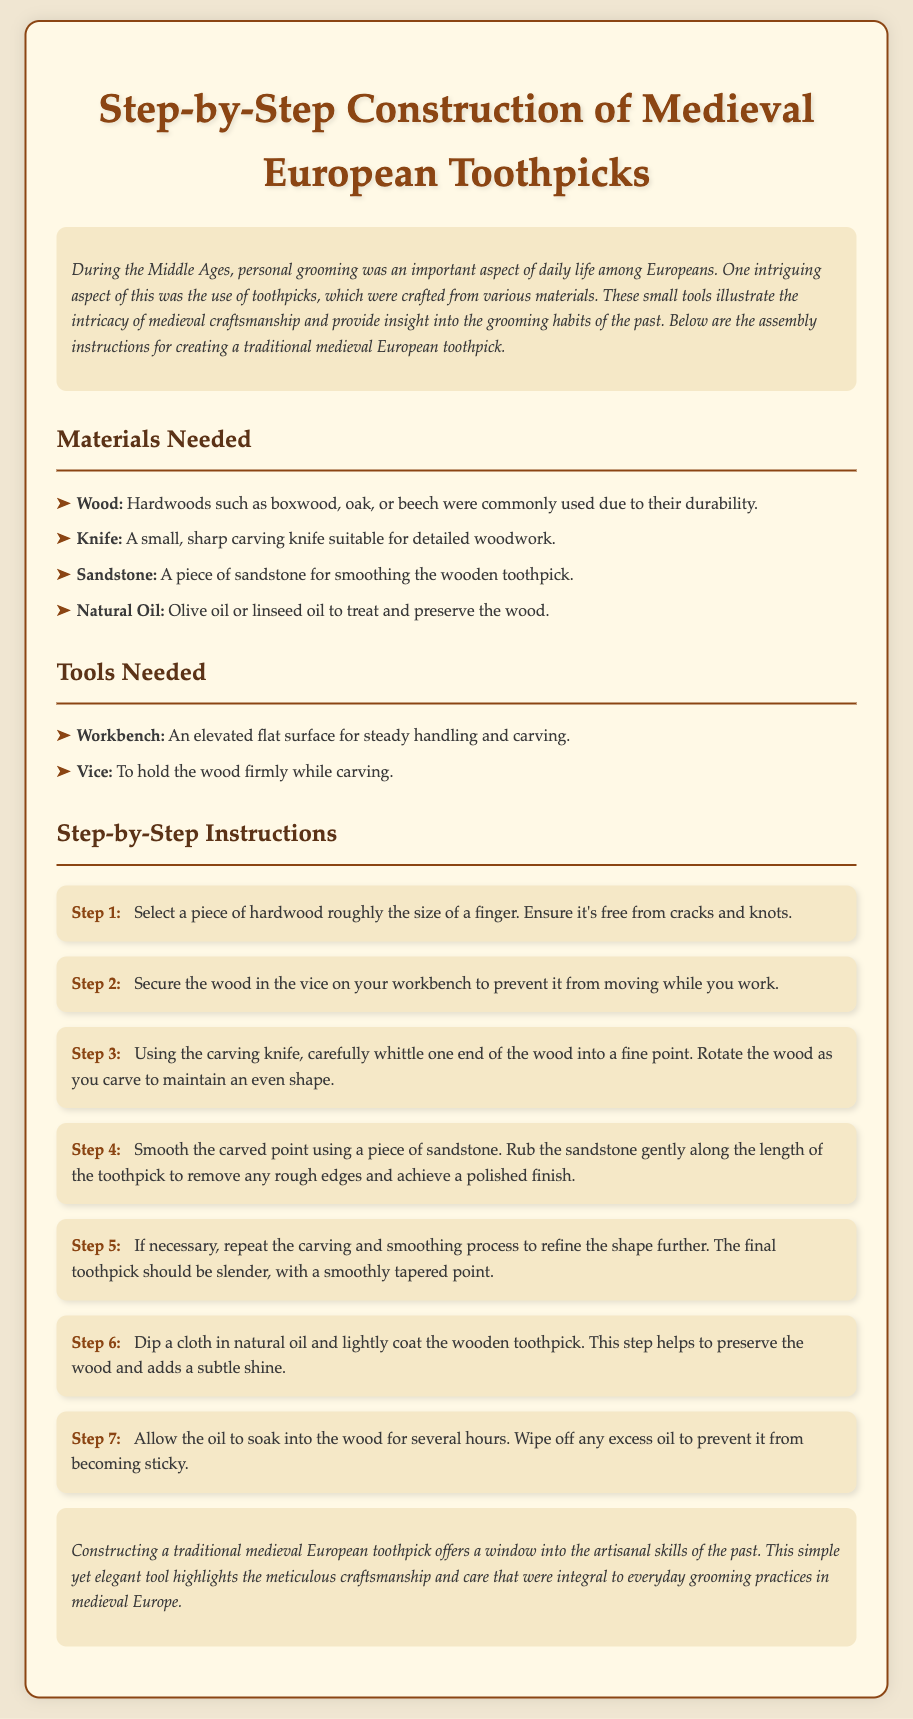What is the title of the document? The title is presented prominently at the top of the document, stating the focus of the instructions.
Answer: Step-by-Step Construction of Medieval European Toothpicks What materials are needed for construction? The section lists specific items that are essential for creating the toothpick.
Answer: Wood, Knife, Sandstone, Natural Oil What is the first step in the construction process? The initial instruction outlines the very first action to take when starting the toothpick.
Answer: Select a piece of hardwood roughly the size of a finger How many steps are included in the instructions? By counting the numbered steps in the instructions, one can determine total steps involved.
Answer: 7 Which wood types are suggested for making the toothpick? The materials section specifies types of wood that are suitable for this task.
Answer: Boxwood, oak, beech What purpose does the natural oil serve in the construction? The document explains how the natural oil contributes to the finished product.
Answer: To treat and preserve the wood What tool is required to hold the wood while carving? The tools section mentions a specific item used for this function during the crafting process.
Answer: Vice What should be done after oiling the toothpick? The document indicates a necessary action following the oil application.
Answer: Allow the oil to soak into the wood for several hours 